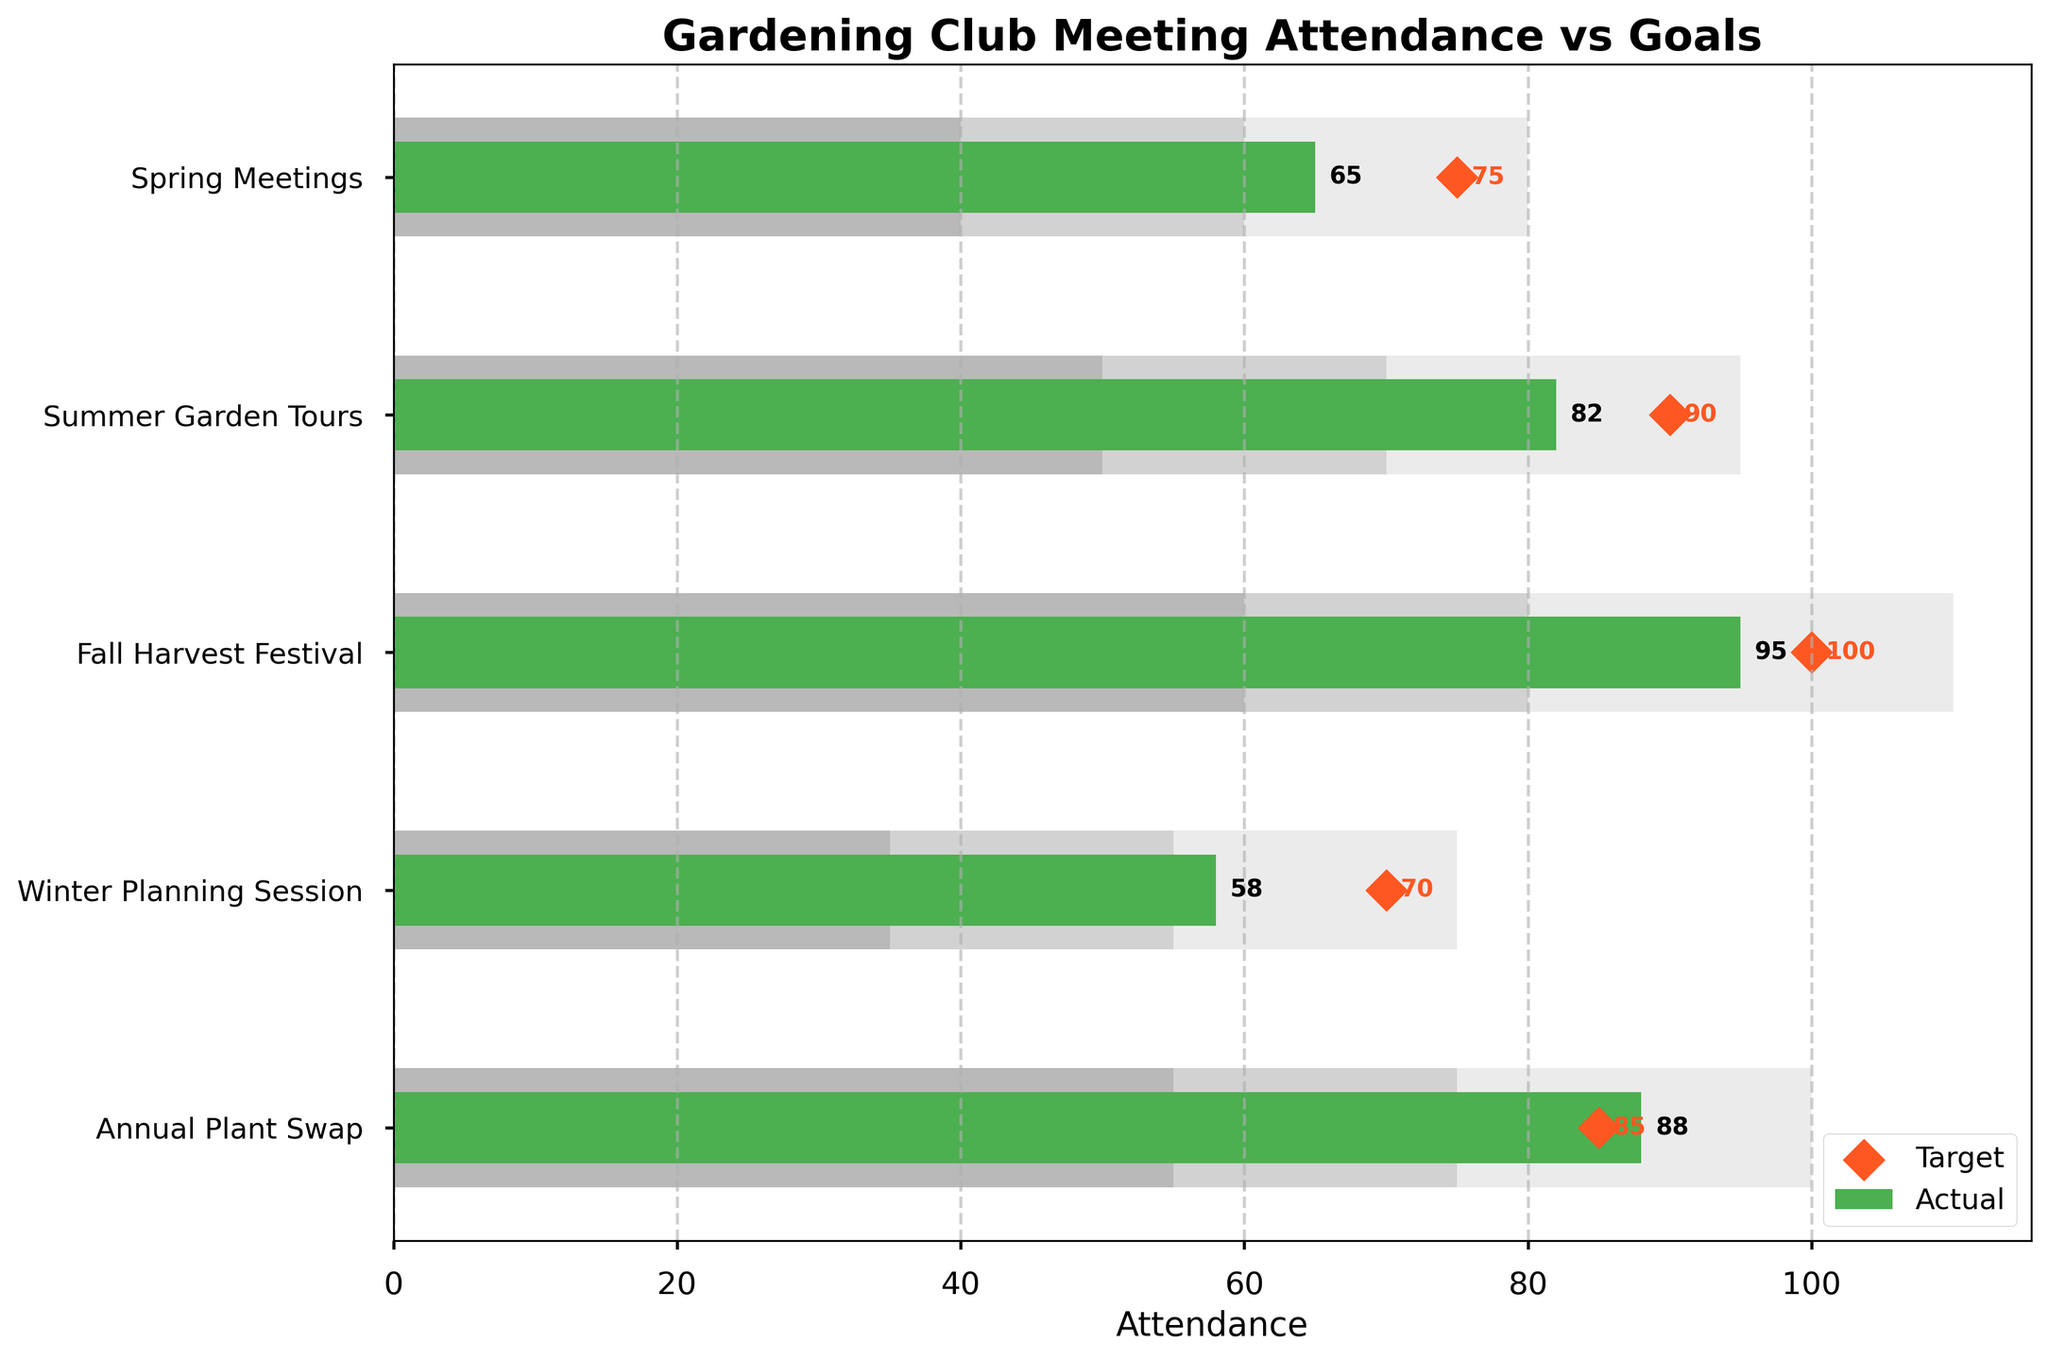How many categories are represented in the figure? There are five different labels on the vertical axis, each representing a category.
Answer: 5 What's the title of the figure? The title is displayed prominently at the top of the chart.
Answer: Gardening Club Meeting Attendance vs Goals Which meeting had the highest actual attendance? By looking at the green bars representing actual attendance, the Fall Harvest Festival has the longest bar.
Answer: Fall Harvest Festival What is the difference between the actual attendance and the target for the Annual Plant Swap? The actual attendance for the Annual Plant Swap is 88, and the target is 85. The difference is 88 - 85.
Answer: 3 Which meetings did not reach their target attendance? Compare the green bars to the diamond markers; Spring Meetings, Summer Garden Tours, Winter Planning Session are below their respective targets.
Answer: Spring Meetings, Summer Garden Tours, Winter Planning Session What's the average target for all categories? Sum the target values for all categories (75 + 90 + 100 + 70 + 85) and divide by the number of categories (5). The average is 420 / 5.
Answer: 84 In which meeting was the actual attendance closest to the target? Compare the differences between each actual and target values; Annual Plant Swap has a difference of 3, which is the smallest.
Answer: Annual Plant Swap What is the lowest value for the second range (Range2) among all categories? Check the second range values; the lowest is for Winter Planning Session, which is 55.
Answer: 55 Which meeting had the smallest actual attendance? By examining the green bars, Winter Planning Session has the shortest bar.
Answer: Winter Planning Session What is the total attendance across all categories? Sum up the actual attendance values (65 + 82 + 95 + 58 + 88). The total is 388.
Answer: 388 